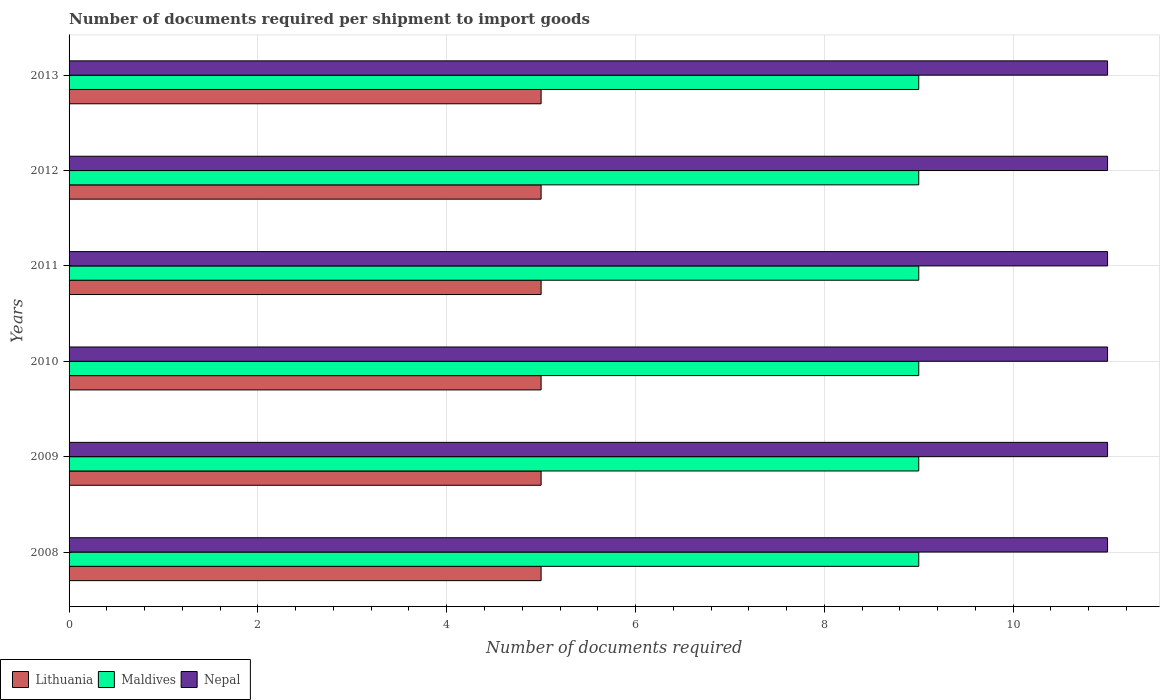How many different coloured bars are there?
Keep it short and to the point. 3. Are the number of bars per tick equal to the number of legend labels?
Provide a succinct answer. Yes. Are the number of bars on each tick of the Y-axis equal?
Your answer should be very brief. Yes. What is the number of documents required per shipment to import goods in Lithuania in 2012?
Your answer should be very brief. 5. Across all years, what is the maximum number of documents required per shipment to import goods in Lithuania?
Ensure brevity in your answer.  5. Across all years, what is the minimum number of documents required per shipment to import goods in Nepal?
Your answer should be very brief. 11. What is the total number of documents required per shipment to import goods in Maldives in the graph?
Your answer should be very brief. 54. What is the difference between the number of documents required per shipment to import goods in Maldives in 2012 and that in 2013?
Your response must be concise. 0. What is the difference between the number of documents required per shipment to import goods in Lithuania in 2009 and the number of documents required per shipment to import goods in Maldives in 2012?
Your answer should be very brief. -4. In the year 2011, what is the difference between the number of documents required per shipment to import goods in Lithuania and number of documents required per shipment to import goods in Nepal?
Offer a very short reply. -6. What is the ratio of the number of documents required per shipment to import goods in Nepal in 2009 to that in 2011?
Your response must be concise. 1. Is the difference between the number of documents required per shipment to import goods in Lithuania in 2008 and 2011 greater than the difference between the number of documents required per shipment to import goods in Nepal in 2008 and 2011?
Your response must be concise. No. In how many years, is the number of documents required per shipment to import goods in Nepal greater than the average number of documents required per shipment to import goods in Nepal taken over all years?
Offer a terse response. 0. Is the sum of the number of documents required per shipment to import goods in Lithuania in 2010 and 2012 greater than the maximum number of documents required per shipment to import goods in Maldives across all years?
Ensure brevity in your answer.  Yes. What does the 1st bar from the top in 2010 represents?
Provide a short and direct response. Nepal. What does the 3rd bar from the bottom in 2008 represents?
Your answer should be compact. Nepal. Is it the case that in every year, the sum of the number of documents required per shipment to import goods in Lithuania and number of documents required per shipment to import goods in Nepal is greater than the number of documents required per shipment to import goods in Maldives?
Offer a very short reply. Yes. What is the difference between two consecutive major ticks on the X-axis?
Offer a very short reply. 2. Are the values on the major ticks of X-axis written in scientific E-notation?
Offer a very short reply. No. Where does the legend appear in the graph?
Offer a very short reply. Bottom left. What is the title of the graph?
Provide a short and direct response. Number of documents required per shipment to import goods. What is the label or title of the X-axis?
Provide a short and direct response. Number of documents required. What is the label or title of the Y-axis?
Offer a very short reply. Years. What is the Number of documents required of Maldives in 2008?
Keep it short and to the point. 9. What is the Number of documents required of Nepal in 2008?
Provide a succinct answer. 11. What is the Number of documents required in Maldives in 2010?
Offer a terse response. 9. What is the Number of documents required in Lithuania in 2011?
Your answer should be compact. 5. What is the Number of documents required in Maldives in 2011?
Provide a short and direct response. 9. What is the Number of documents required of Nepal in 2011?
Offer a terse response. 11. What is the Number of documents required of Lithuania in 2012?
Provide a succinct answer. 5. What is the Number of documents required of Maldives in 2012?
Your answer should be very brief. 9. What is the Number of documents required in Nepal in 2012?
Provide a short and direct response. 11. What is the Number of documents required in Maldives in 2013?
Your response must be concise. 9. What is the Number of documents required of Nepal in 2013?
Provide a short and direct response. 11. Across all years, what is the maximum Number of documents required of Lithuania?
Provide a short and direct response. 5. Across all years, what is the minimum Number of documents required of Lithuania?
Keep it short and to the point. 5. Across all years, what is the minimum Number of documents required of Maldives?
Provide a succinct answer. 9. Across all years, what is the minimum Number of documents required of Nepal?
Provide a succinct answer. 11. What is the total Number of documents required of Lithuania in the graph?
Keep it short and to the point. 30. What is the difference between the Number of documents required in Lithuania in 2008 and that in 2010?
Your answer should be compact. 0. What is the difference between the Number of documents required of Maldives in 2008 and that in 2010?
Your answer should be very brief. 0. What is the difference between the Number of documents required in Nepal in 2008 and that in 2010?
Your answer should be very brief. 0. What is the difference between the Number of documents required in Maldives in 2008 and that in 2011?
Ensure brevity in your answer.  0. What is the difference between the Number of documents required of Nepal in 2008 and that in 2011?
Provide a succinct answer. 0. What is the difference between the Number of documents required in Lithuania in 2008 and that in 2012?
Give a very brief answer. 0. What is the difference between the Number of documents required in Nepal in 2008 and that in 2012?
Your answer should be compact. 0. What is the difference between the Number of documents required in Lithuania in 2008 and that in 2013?
Your answer should be very brief. 0. What is the difference between the Number of documents required of Maldives in 2008 and that in 2013?
Provide a short and direct response. 0. What is the difference between the Number of documents required in Lithuania in 2009 and that in 2010?
Your answer should be compact. 0. What is the difference between the Number of documents required in Maldives in 2009 and that in 2010?
Ensure brevity in your answer.  0. What is the difference between the Number of documents required of Nepal in 2009 and that in 2010?
Your answer should be very brief. 0. What is the difference between the Number of documents required in Lithuania in 2009 and that in 2011?
Keep it short and to the point. 0. What is the difference between the Number of documents required in Maldives in 2009 and that in 2011?
Your answer should be very brief. 0. What is the difference between the Number of documents required in Nepal in 2009 and that in 2011?
Keep it short and to the point. 0. What is the difference between the Number of documents required of Nepal in 2009 and that in 2012?
Offer a very short reply. 0. What is the difference between the Number of documents required of Lithuania in 2009 and that in 2013?
Give a very brief answer. 0. What is the difference between the Number of documents required of Maldives in 2009 and that in 2013?
Your answer should be compact. 0. What is the difference between the Number of documents required in Lithuania in 2010 and that in 2011?
Make the answer very short. 0. What is the difference between the Number of documents required of Maldives in 2010 and that in 2011?
Offer a terse response. 0. What is the difference between the Number of documents required in Nepal in 2010 and that in 2011?
Provide a succinct answer. 0. What is the difference between the Number of documents required of Maldives in 2010 and that in 2012?
Make the answer very short. 0. What is the difference between the Number of documents required in Nepal in 2010 and that in 2012?
Keep it short and to the point. 0. What is the difference between the Number of documents required of Maldives in 2011 and that in 2012?
Give a very brief answer. 0. What is the difference between the Number of documents required of Lithuania in 2011 and that in 2013?
Your answer should be very brief. 0. What is the difference between the Number of documents required of Maldives in 2011 and that in 2013?
Keep it short and to the point. 0. What is the difference between the Number of documents required of Nepal in 2011 and that in 2013?
Offer a very short reply. 0. What is the difference between the Number of documents required of Maldives in 2012 and that in 2013?
Provide a succinct answer. 0. What is the difference between the Number of documents required in Maldives in 2008 and the Number of documents required in Nepal in 2009?
Your response must be concise. -2. What is the difference between the Number of documents required of Lithuania in 2008 and the Number of documents required of Nepal in 2010?
Provide a succinct answer. -6. What is the difference between the Number of documents required in Maldives in 2008 and the Number of documents required in Nepal in 2010?
Offer a very short reply. -2. What is the difference between the Number of documents required in Lithuania in 2008 and the Number of documents required in Nepal in 2011?
Make the answer very short. -6. What is the difference between the Number of documents required of Lithuania in 2008 and the Number of documents required of Maldives in 2012?
Your answer should be very brief. -4. What is the difference between the Number of documents required in Lithuania in 2008 and the Number of documents required in Nepal in 2012?
Provide a succinct answer. -6. What is the difference between the Number of documents required in Maldives in 2008 and the Number of documents required in Nepal in 2012?
Give a very brief answer. -2. What is the difference between the Number of documents required in Lithuania in 2008 and the Number of documents required in Maldives in 2013?
Offer a very short reply. -4. What is the difference between the Number of documents required in Lithuania in 2008 and the Number of documents required in Nepal in 2013?
Provide a short and direct response. -6. What is the difference between the Number of documents required in Maldives in 2008 and the Number of documents required in Nepal in 2013?
Provide a short and direct response. -2. What is the difference between the Number of documents required of Lithuania in 2009 and the Number of documents required of Maldives in 2010?
Your answer should be very brief. -4. What is the difference between the Number of documents required of Lithuania in 2009 and the Number of documents required of Nepal in 2010?
Offer a terse response. -6. What is the difference between the Number of documents required of Maldives in 2009 and the Number of documents required of Nepal in 2010?
Provide a succinct answer. -2. What is the difference between the Number of documents required in Lithuania in 2009 and the Number of documents required in Nepal in 2011?
Offer a terse response. -6. What is the difference between the Number of documents required of Maldives in 2009 and the Number of documents required of Nepal in 2011?
Give a very brief answer. -2. What is the difference between the Number of documents required of Lithuania in 2009 and the Number of documents required of Maldives in 2012?
Ensure brevity in your answer.  -4. What is the difference between the Number of documents required in Lithuania in 2009 and the Number of documents required in Maldives in 2013?
Make the answer very short. -4. What is the difference between the Number of documents required of Lithuania in 2009 and the Number of documents required of Nepal in 2013?
Offer a very short reply. -6. What is the difference between the Number of documents required in Lithuania in 2010 and the Number of documents required in Nepal in 2011?
Your answer should be compact. -6. What is the difference between the Number of documents required in Lithuania in 2010 and the Number of documents required in Maldives in 2012?
Your answer should be compact. -4. What is the difference between the Number of documents required in Maldives in 2010 and the Number of documents required in Nepal in 2012?
Keep it short and to the point. -2. What is the difference between the Number of documents required of Lithuania in 2010 and the Number of documents required of Nepal in 2013?
Provide a succinct answer. -6. What is the difference between the Number of documents required in Lithuania in 2011 and the Number of documents required in Maldives in 2012?
Your answer should be compact. -4. What is the difference between the Number of documents required of Maldives in 2011 and the Number of documents required of Nepal in 2012?
Ensure brevity in your answer.  -2. What is the difference between the Number of documents required of Lithuania in 2011 and the Number of documents required of Nepal in 2013?
Your response must be concise. -6. What is the average Number of documents required in Nepal per year?
Give a very brief answer. 11. In the year 2008, what is the difference between the Number of documents required of Lithuania and Number of documents required of Maldives?
Provide a short and direct response. -4. In the year 2008, what is the difference between the Number of documents required in Maldives and Number of documents required in Nepal?
Give a very brief answer. -2. In the year 2009, what is the difference between the Number of documents required in Lithuania and Number of documents required in Maldives?
Keep it short and to the point. -4. In the year 2009, what is the difference between the Number of documents required of Maldives and Number of documents required of Nepal?
Ensure brevity in your answer.  -2. In the year 2010, what is the difference between the Number of documents required of Lithuania and Number of documents required of Maldives?
Make the answer very short. -4. In the year 2010, what is the difference between the Number of documents required of Maldives and Number of documents required of Nepal?
Provide a short and direct response. -2. In the year 2011, what is the difference between the Number of documents required of Lithuania and Number of documents required of Maldives?
Make the answer very short. -4. In the year 2011, what is the difference between the Number of documents required of Maldives and Number of documents required of Nepal?
Your answer should be very brief. -2. In the year 2013, what is the difference between the Number of documents required in Lithuania and Number of documents required in Nepal?
Give a very brief answer. -6. What is the ratio of the Number of documents required in Nepal in 2008 to that in 2010?
Keep it short and to the point. 1. What is the ratio of the Number of documents required of Lithuania in 2008 to that in 2011?
Keep it short and to the point. 1. What is the ratio of the Number of documents required in Nepal in 2008 to that in 2011?
Provide a succinct answer. 1. What is the ratio of the Number of documents required in Nepal in 2008 to that in 2013?
Offer a terse response. 1. What is the ratio of the Number of documents required in Lithuania in 2009 to that in 2012?
Provide a short and direct response. 1. What is the ratio of the Number of documents required of Nepal in 2009 to that in 2012?
Keep it short and to the point. 1. What is the ratio of the Number of documents required in Lithuania in 2009 to that in 2013?
Keep it short and to the point. 1. What is the ratio of the Number of documents required in Maldives in 2009 to that in 2013?
Make the answer very short. 1. What is the ratio of the Number of documents required in Nepal in 2009 to that in 2013?
Provide a succinct answer. 1. What is the ratio of the Number of documents required of Lithuania in 2010 to that in 2011?
Your answer should be very brief. 1. What is the ratio of the Number of documents required of Maldives in 2010 to that in 2011?
Offer a terse response. 1. What is the ratio of the Number of documents required in Nepal in 2010 to that in 2011?
Provide a short and direct response. 1. What is the ratio of the Number of documents required of Lithuania in 2010 to that in 2012?
Keep it short and to the point. 1. What is the ratio of the Number of documents required in Lithuania in 2010 to that in 2013?
Your answer should be compact. 1. What is the ratio of the Number of documents required of Lithuania in 2011 to that in 2012?
Offer a very short reply. 1. What is the ratio of the Number of documents required in Maldives in 2011 to that in 2012?
Offer a terse response. 1. What is the ratio of the Number of documents required in Maldives in 2011 to that in 2013?
Provide a succinct answer. 1. What is the ratio of the Number of documents required in Nepal in 2011 to that in 2013?
Ensure brevity in your answer.  1. What is the ratio of the Number of documents required of Lithuania in 2012 to that in 2013?
Keep it short and to the point. 1. What is the ratio of the Number of documents required of Nepal in 2012 to that in 2013?
Your answer should be compact. 1. What is the difference between the highest and the second highest Number of documents required of Maldives?
Ensure brevity in your answer.  0. What is the difference between the highest and the lowest Number of documents required in Lithuania?
Your answer should be compact. 0. What is the difference between the highest and the lowest Number of documents required in Nepal?
Your answer should be compact. 0. 